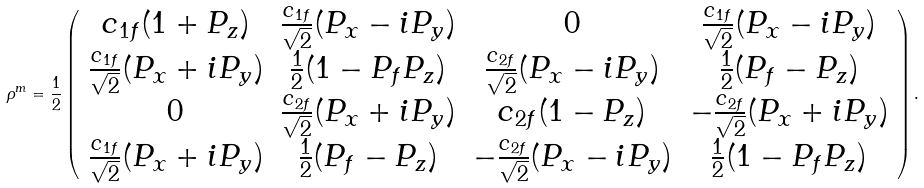Convert formula to latex. <formula><loc_0><loc_0><loc_500><loc_500>\rho ^ { m } = \frac { 1 } { 2 } \left ( \begin{array} { c c c c } c _ { 1 f } ( 1 + P _ { z } ) & \frac { c _ { 1 f } } { \sqrt { 2 } } ( P _ { x } - i P _ { y } ) & 0 & \frac { c _ { 1 f } } { \sqrt { 2 } } ( P _ { x } - i P _ { y } ) \\ \frac { c _ { 1 f } } { \sqrt { 2 } } ( P _ { x } + i P _ { y } ) & \frac { 1 } { 2 } ( 1 - P _ { f } P _ { z } ) & \frac { c _ { 2 f } } { \sqrt { 2 } } ( P _ { x } - i P _ { y } ) & \frac { 1 } { 2 } ( P _ { f } - P _ { z } ) \\ 0 & \frac { c _ { 2 f } } { \sqrt { 2 } } ( P _ { x } + i P _ { y } ) & c _ { 2 f } ( 1 - P _ { z } ) & - \frac { c _ { 2 f } } { \sqrt { 2 } } ( P _ { x } + i P _ { y } ) \\ \frac { c _ { 1 f } } { \sqrt { 2 } } ( P _ { x } + i P _ { y } ) & \frac { 1 } { 2 } ( P _ { f } - P _ { z } ) & - \frac { c _ { 2 f } } { \sqrt { 2 } } ( P _ { x } - i P _ { y } ) & \frac { 1 } { 2 } ( 1 - P _ { f } P _ { z } ) \end{array} \right ) .</formula> 